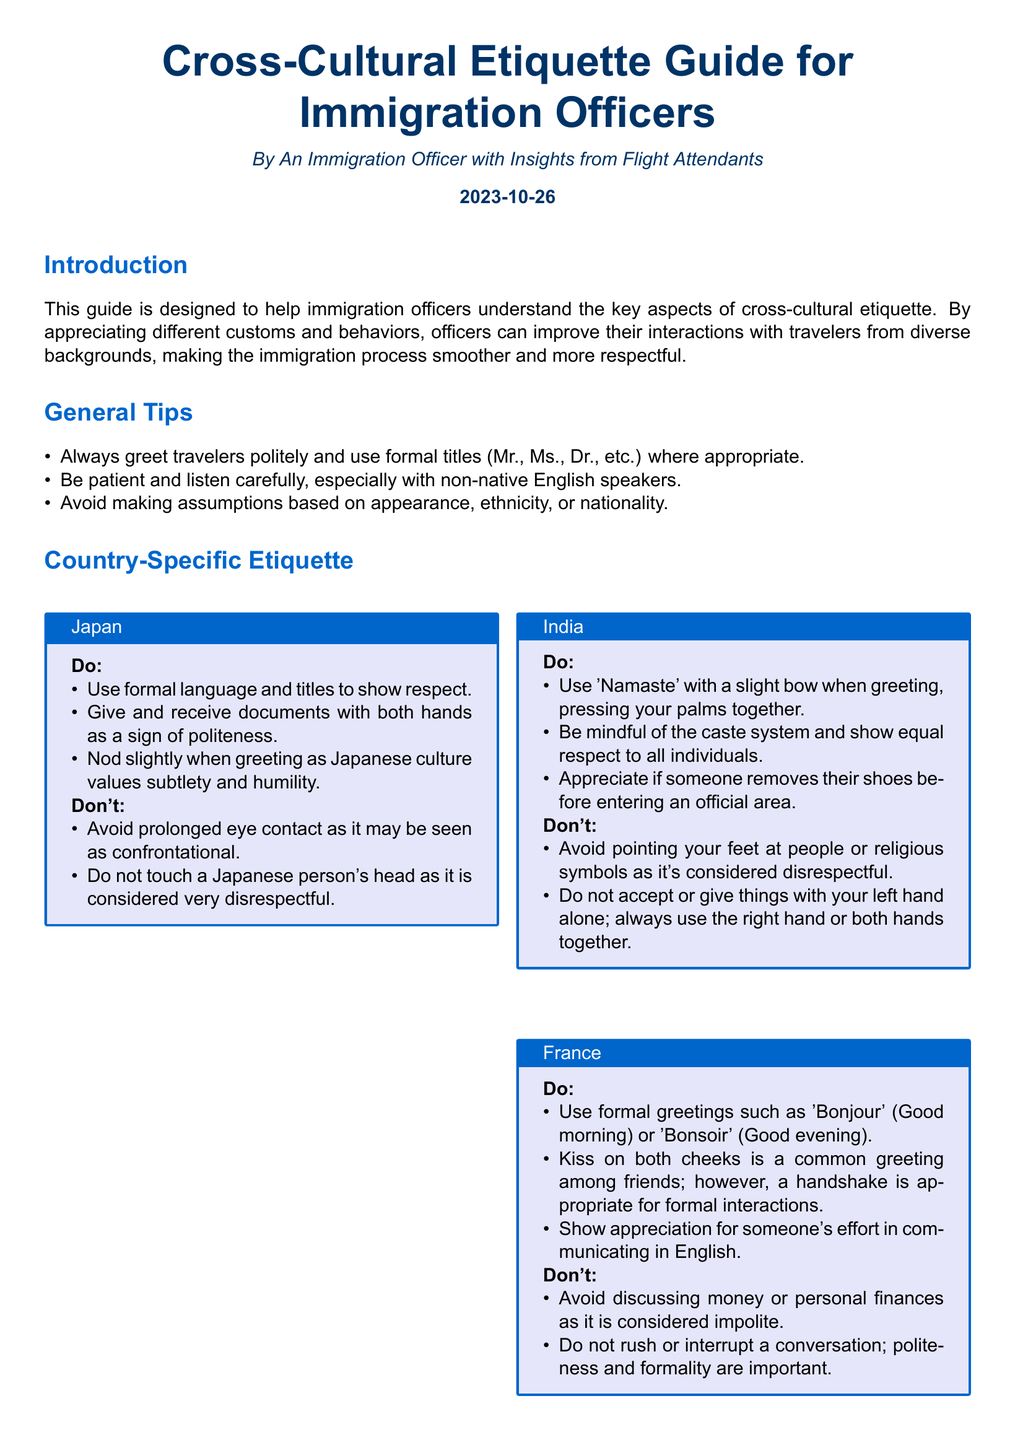What is the date of the document? The date of the document is explicitly mentioned at the bottom of the introduction section.
Answer: 2023-10-26 Which greeting is suggested for India? The document provides specific greetings for each nationality, and for India, it suggests using 'Namaste' with a slight bow.
Answer: Namaste How should documents be exchanged in Japan? The guidelines specifically state that documents should be given and received with both hands as a sign of politeness.
Answer: Both hands What is one cultural gesture to avoid in Brazil? The document lists specific behaviors to avoid in Brazil, one of which is using the 'OK' gesture as it can be offensive.
Answer: OK gesture What is emphasized in the conclusion section? The conclusion encapsulates the overall message and states that understanding cross-cultural differences is crucial for immigration officers.
Answer: Understanding cross-cultural differences What is a polite request regarding titles? The document includes general tips that highlight the importance of formal titles in interactions.
Answer: Use formal titles What is a recommended greeting in France? The document suggests a formal greeting for France, highlighting the importance of 'Bonjour' or 'Bonsoir.'
Answer: Bonjour How should one interact with non-native English speakers? The guidelines emphasize patience and careful listening when dealing with non-native English speakers.
Answer: Be patient 